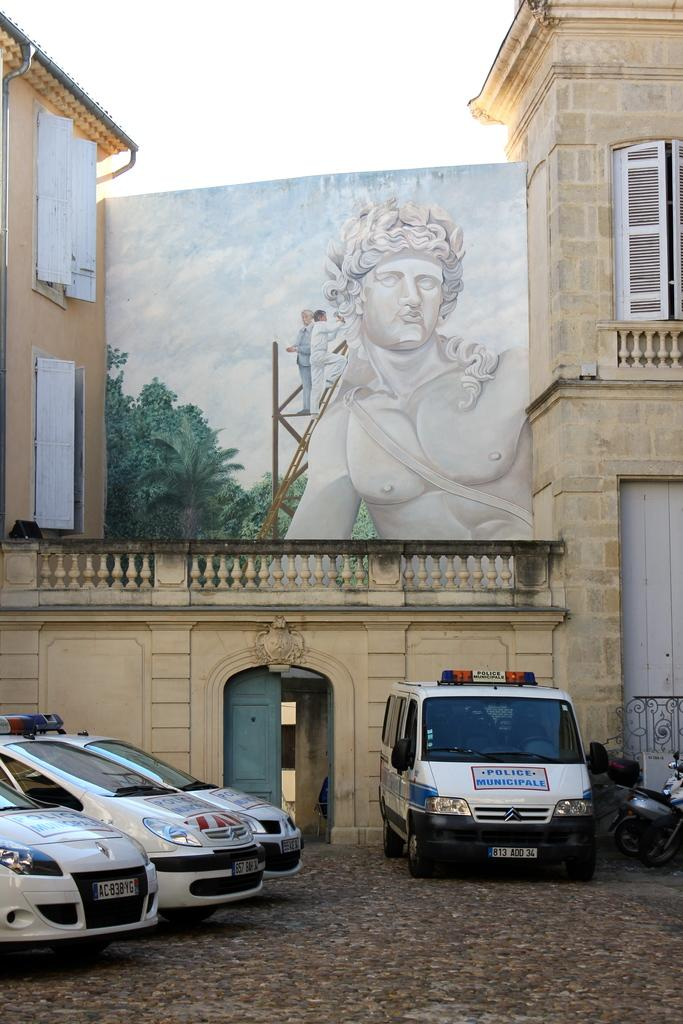What is located between the buildings in the image? There is a painting between the buildings in the image. What can be seen at the bottom of the image? Cars are visible at the bottom of the image. Can you describe a specific feature of the buildings? There is a door in the image. What is visible in the background of the image? The sky is visible in the background of the image. What type of bone is being used as a doorstop in the image? There is no bone present in the image, and therefore no bone is being used as a doorstop. Can you tell me how many bags of popcorn are visible in the image? There is no popcorn present in the image, so it is not possible to determine the number of bags. 